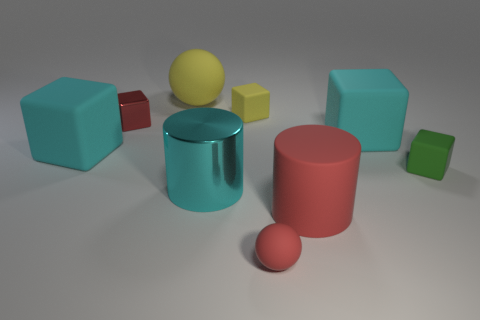Subtract all yellow blocks. How many blocks are left? 4 Subtract all cyan cylinders. How many cylinders are left? 1 Subtract 1 balls. How many balls are left? 1 Subtract all yellow balls. How many blue blocks are left? 0 Subtract all small matte objects. Subtract all small matte balls. How many objects are left? 5 Add 6 large cyan shiny objects. How many large cyan shiny objects are left? 7 Add 9 tiny red metallic blocks. How many tiny red metallic blocks exist? 10 Subtract 0 gray cylinders. How many objects are left? 9 Subtract all cylinders. How many objects are left? 7 Subtract all red cylinders. Subtract all gray cubes. How many cylinders are left? 1 